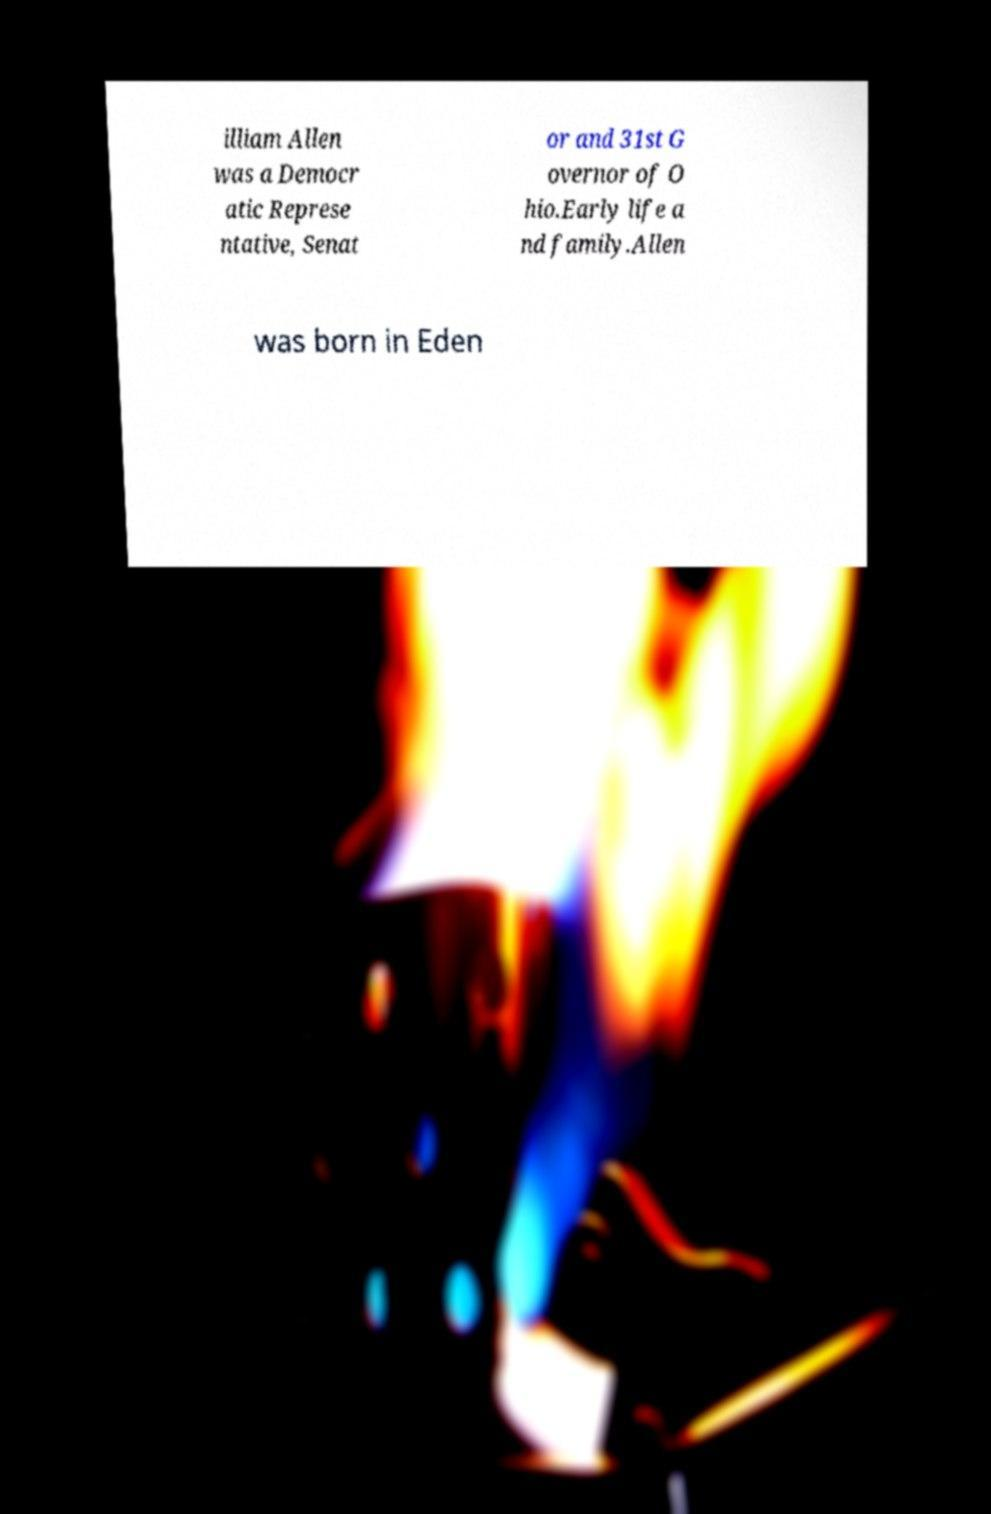There's text embedded in this image that I need extracted. Can you transcribe it verbatim? illiam Allen was a Democr atic Represe ntative, Senat or and 31st G overnor of O hio.Early life a nd family.Allen was born in Eden 